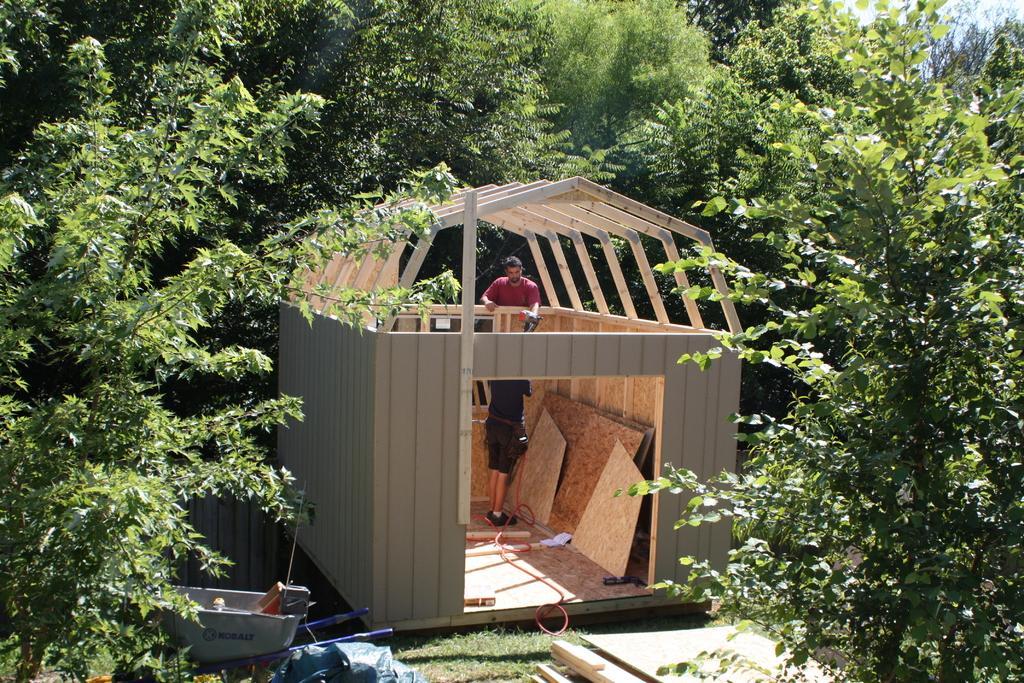How would you summarize this image in a sentence or two? In this image there are two men in the middle who are constructing the wooden house. On the left side bottom there is a trolley. In the trolley there are tools. There are trees around the wooden house. At the bottom there are wooden sticks. 